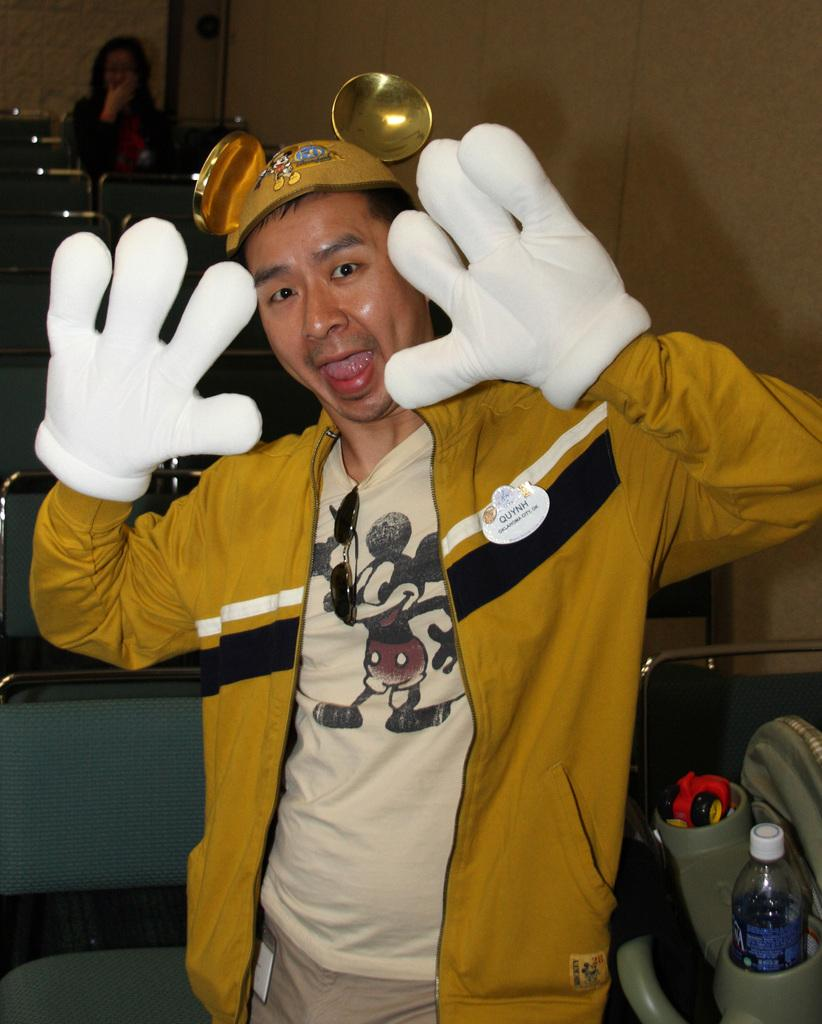What is the main subject of the image? There is a man standing in the center of the image. What is the man wearing in the image? The man is wearing a jacket. What object is placed next to the man? There is a bottle placed in a seat next to the man. Can you describe the background of the image? There is a lady and a wall in the background of the image. What type of hat is the man wearing in the image? The man is not wearing a hat in the image. Can you tell me how many boots are visible in the image? There are no boots present in the image. 